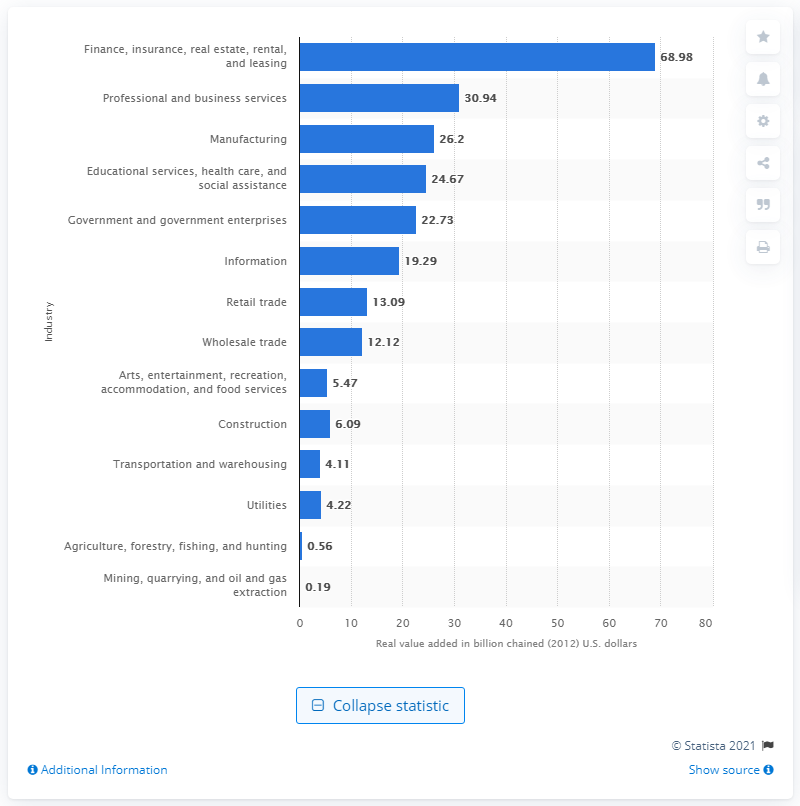Can you tell me the range of contributions from industries to Connecticut's GDP? According to the chart, the range of contributions to Connecticut’s GDP spans from $0.19 billion in the mining, quarrying, and oil and gas extraction industry to $68.98 billion in the finance, insurance, real estate, rental, and leasing industry. 